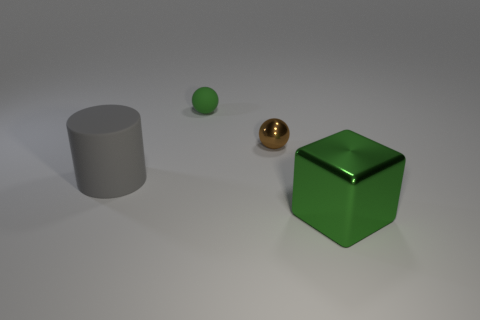Subtract all brown spheres. How many spheres are left? 1 Add 2 big cylinders. How many objects exist? 6 Subtract all cubes. How many objects are left? 3 Subtract all purple balls. Subtract all yellow cylinders. How many balls are left? 2 Subtract all brown cubes. How many blue balls are left? 0 Subtract all big green objects. Subtract all large cubes. How many objects are left? 2 Add 1 metal balls. How many metal balls are left? 2 Add 1 big cyan rubber cubes. How many big cyan rubber cubes exist? 1 Subtract 0 brown blocks. How many objects are left? 4 